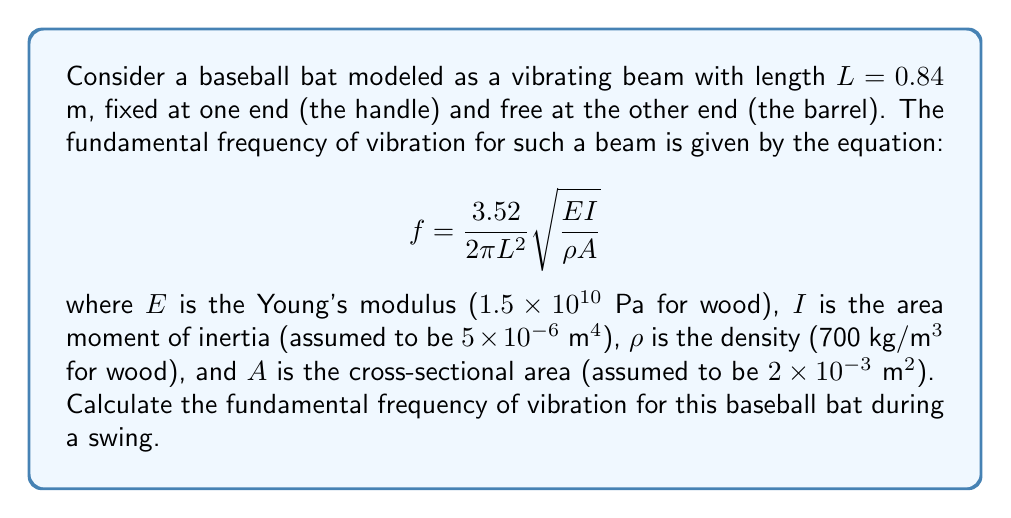Give your solution to this math problem. Let's approach this step-by-step:

1) We are given the following values:
   $L = 0.84$ m
   $E = 1.5 \times 10^{10}$ Pa
   $I = 5 \times 10^{-6}$ m^4
   $\rho = 700$ kg/m^3
   $A = 2 \times 10^{-3}$ m^2

2) We need to substitute these values into the equation:

   $$f = \frac{3.52}{2\pi L^2}\sqrt{\frac{EI}{\rho A}}$$

3) Let's start with the fraction under the square root:

   $$\frac{EI}{\rho A} = \frac{(1.5 \times 10^{10})(5 \times 10^{-6})}{(700)(2 \times 10^{-3})} = 53.57$$

4) Now, let's calculate the square root:

   $$\sqrt{\frac{EI}{\rho A}} = \sqrt{53.57} = 7.32$$

5) Next, let's calculate the denominator outside the square root:

   $$2\pi L^2 = 2\pi(0.84)^2 = 4.43$$

6) Now we can put it all together:

   $$f = \frac{3.52}{4.43}(7.32) = 5.81$$

Therefore, the fundamental frequency of vibration for the baseball bat is approximately 5.81 Hz.
Answer: 5.81 Hz 